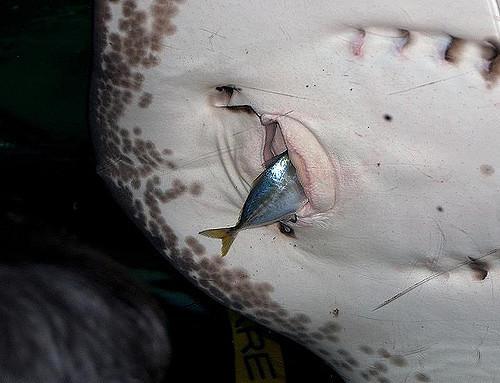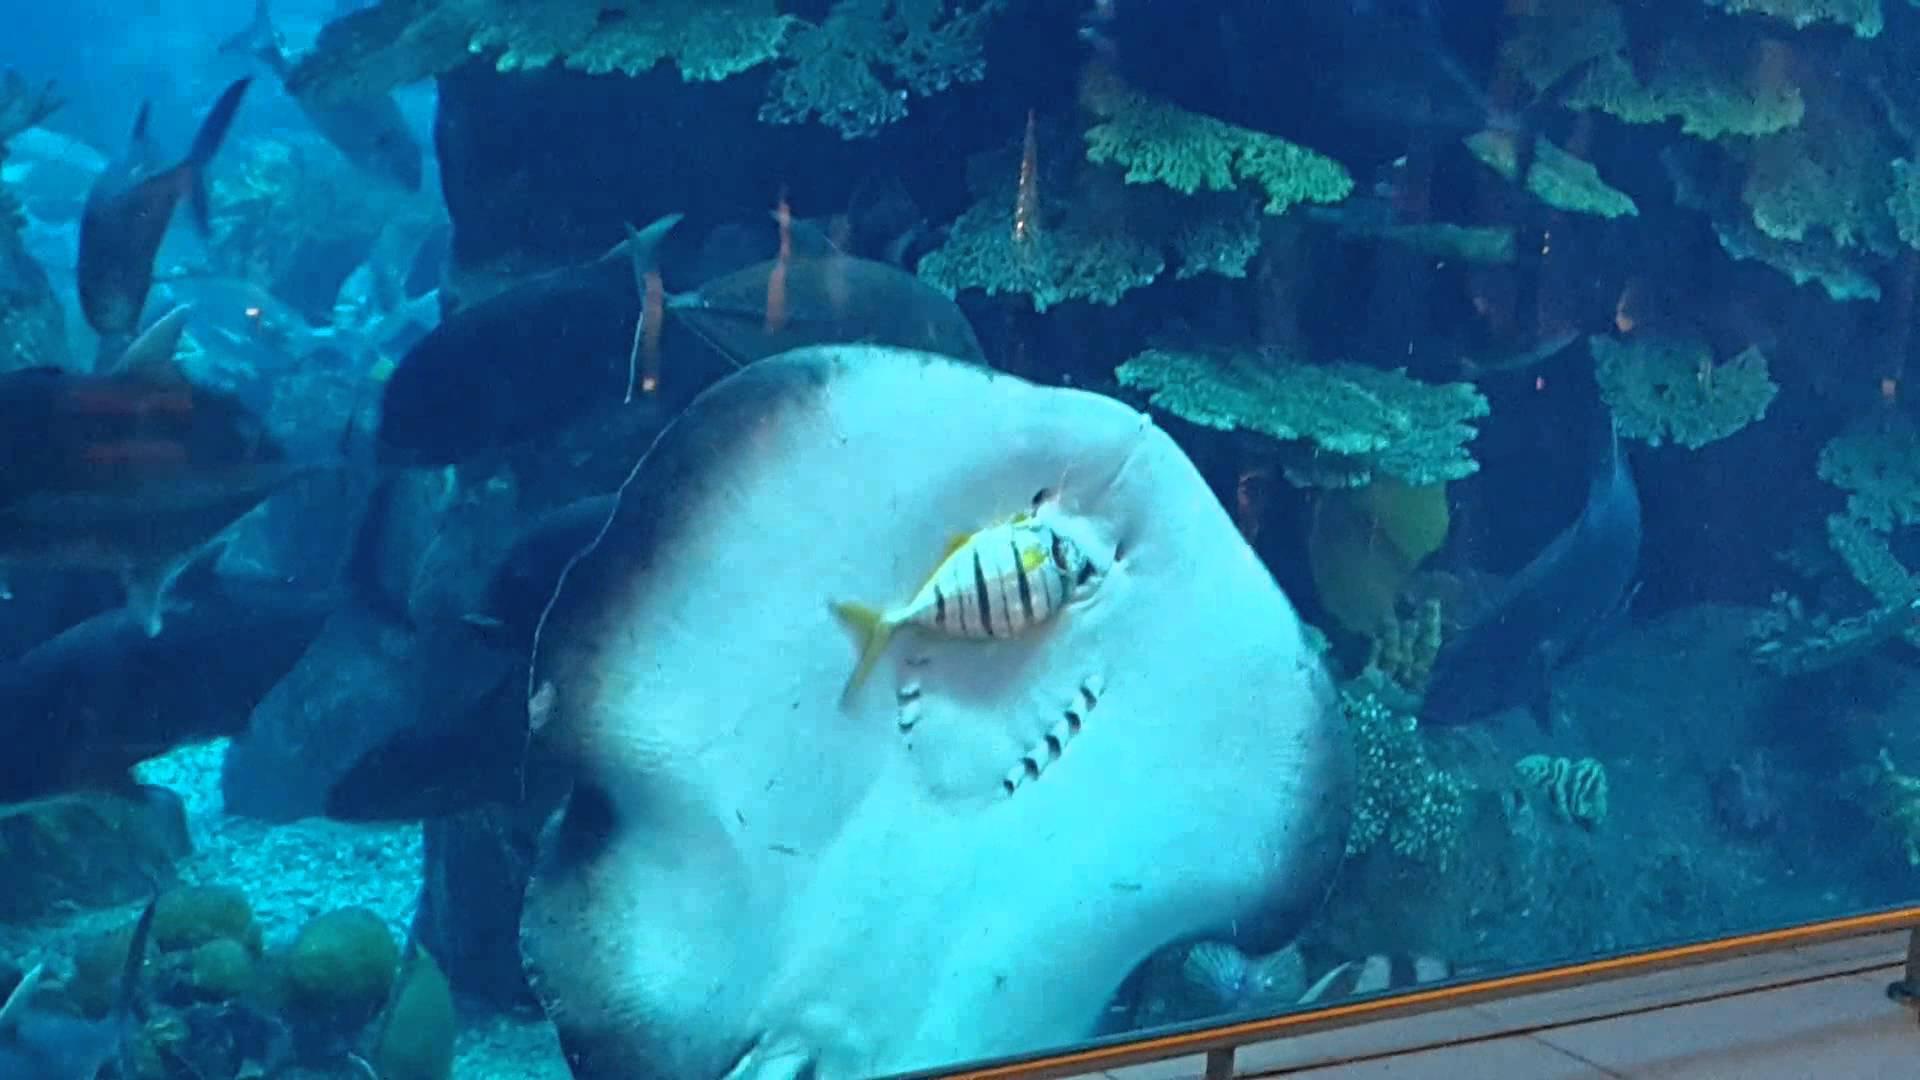The first image is the image on the left, the second image is the image on the right. Analyze the images presented: Is the assertion "A human hand is near the underside of a stingray in one image." valid? Answer yes or no. No. 